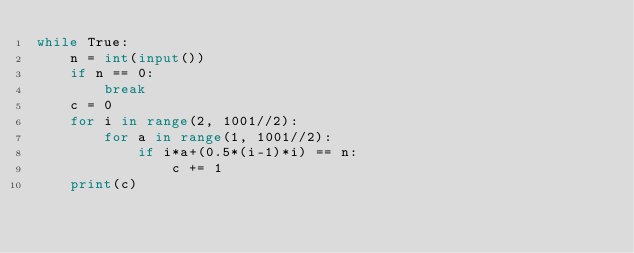Convert code to text. <code><loc_0><loc_0><loc_500><loc_500><_Python_>while True:
    n = int(input())
    if n == 0:
        break
    c = 0
    for i in range(2, 1001//2):
        for a in range(1, 1001//2):
            if i*a+(0.5*(i-1)*i) == n:
                c += 1
    print(c)

</code> 